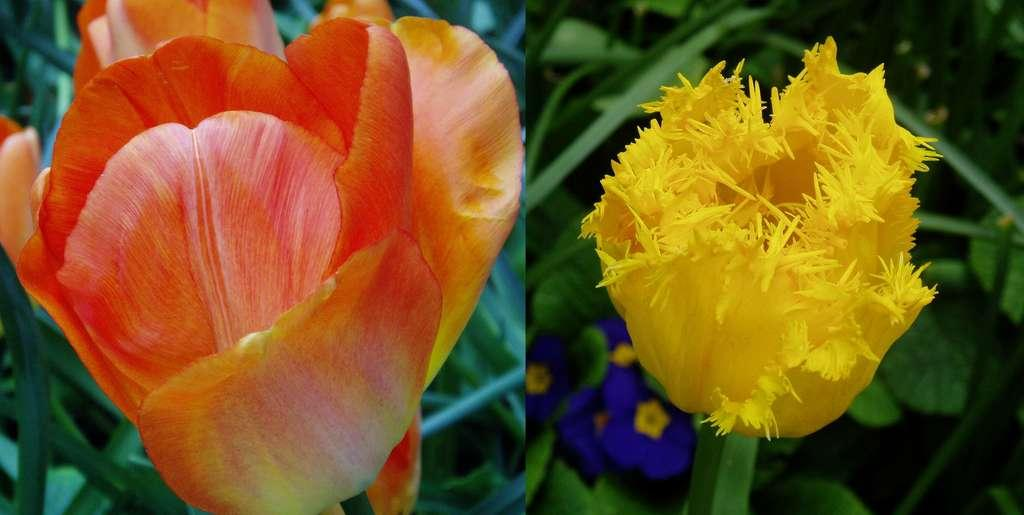What is the main subject of the image? The image contains a collage of two pictures, both depicting flowers. Can you describe the content of the collage? Both pictures in the collage depict flowers. What else can be seen in the background of the image? There are leaves visible in the background of the image. How far away are the friends from each other in the image? There are no friends present in the image, as it only contains a collage of two pictures depicting flowers and leaves in the background. 